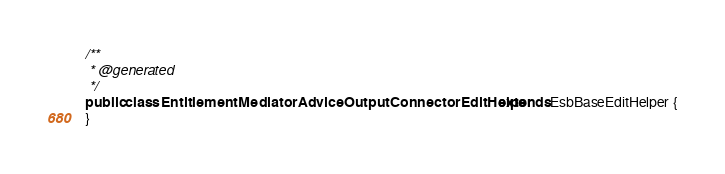Convert code to text. <code><loc_0><loc_0><loc_500><loc_500><_Java_>/**
 * @generated
 */
public class EntitlementMediatorAdviceOutputConnectorEditHelper extends EsbBaseEditHelper {
}
</code> 